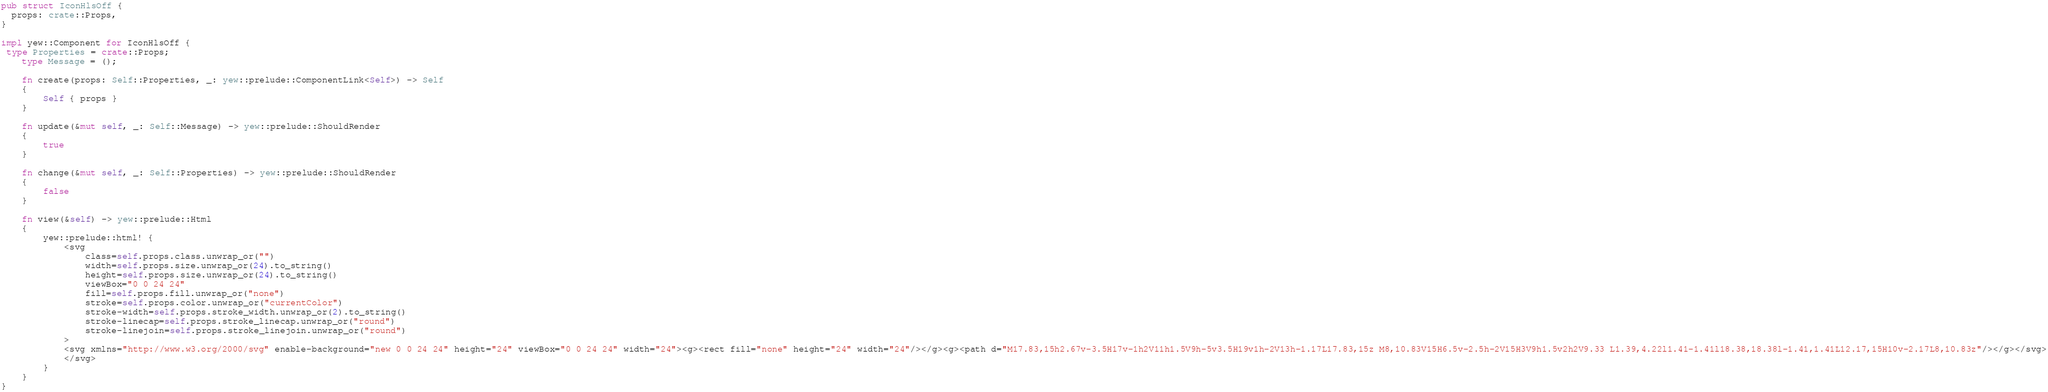<code> <loc_0><loc_0><loc_500><loc_500><_Rust_>
pub struct IconHlsOff {
  props: crate::Props,
}

impl yew::Component for IconHlsOff {
 type Properties = crate::Props;
    type Message = ();

    fn create(props: Self::Properties, _: yew::prelude::ComponentLink<Self>) -> Self
    {
        Self { props }
    }

    fn update(&mut self, _: Self::Message) -> yew::prelude::ShouldRender
    {
        true
    }

    fn change(&mut self, _: Self::Properties) -> yew::prelude::ShouldRender
    {
        false
    }

    fn view(&self) -> yew::prelude::Html
    {
        yew::prelude::html! {
            <svg
                class=self.props.class.unwrap_or("")
                width=self.props.size.unwrap_or(24).to_string()
                height=self.props.size.unwrap_or(24).to_string()
                viewBox="0 0 24 24"
                fill=self.props.fill.unwrap_or("none")
                stroke=self.props.color.unwrap_or("currentColor")
                stroke-width=self.props.stroke_width.unwrap_or(2).to_string()
                stroke-linecap=self.props.stroke_linecap.unwrap_or("round")
                stroke-linejoin=self.props.stroke_linejoin.unwrap_or("round")
            >
            <svg xmlns="http://www.w3.org/2000/svg" enable-background="new 0 0 24 24" height="24" viewBox="0 0 24 24" width="24"><g><rect fill="none" height="24" width="24"/></g><g><path d="M17.83,15h2.67v-3.5H17v-1h2V11h1.5V9h-5v3.5H19v1h-2V13h-1.17L17.83,15z M8,10.83V15H6.5v-2.5h-2V15H3V9h1.5v2h2V9.33 L1.39,4.22l1.41-1.41l18.38,18.38l-1.41,1.41L12.17,15H10v-2.17L8,10.83z"/></g></svg>
            </svg>
        }
    }
}


</code> 